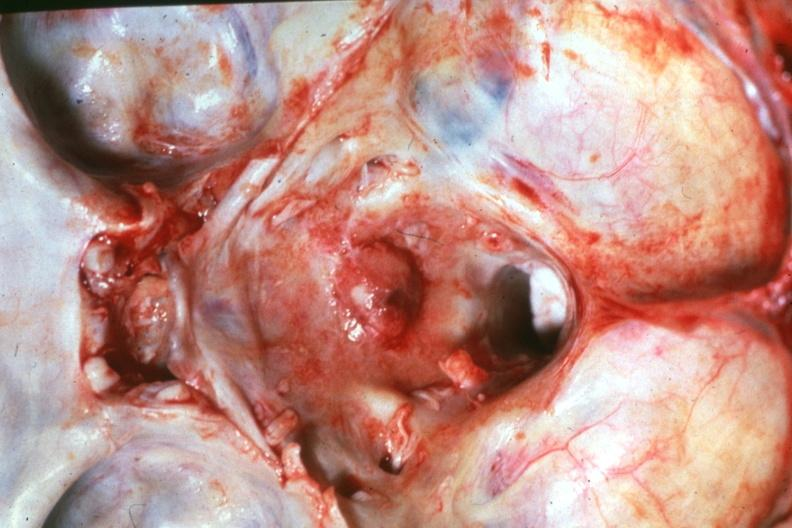s meningioma in posterior fossa present?
Answer the question using a single word or phrase. Yes 